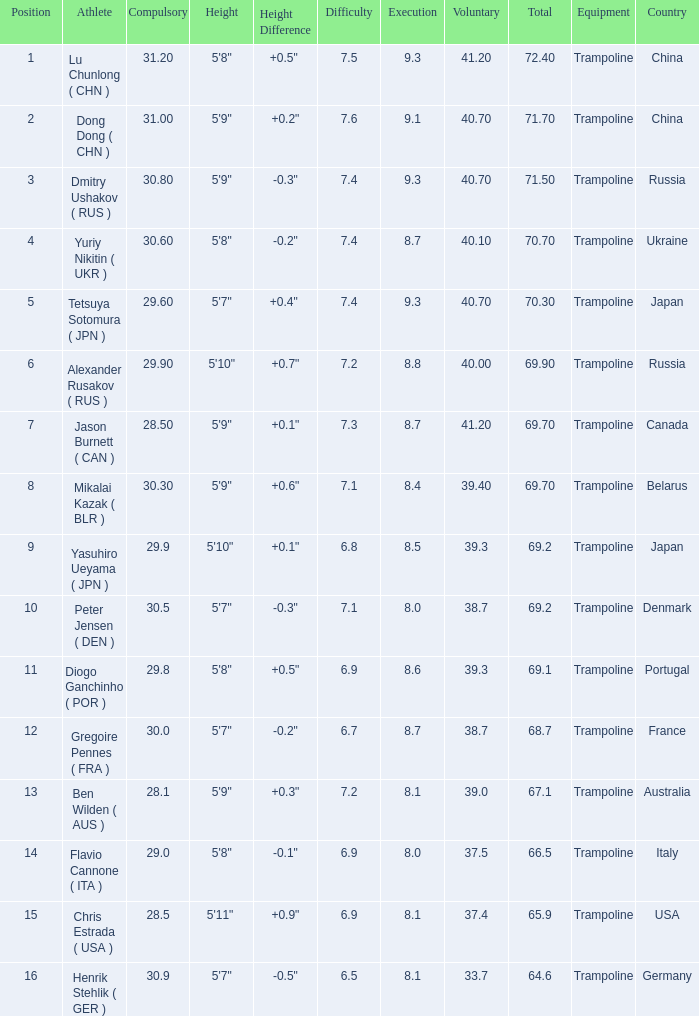Could you parse the entire table as a dict? {'header': ['Position', 'Athlete', 'Compulsory', 'Height', 'Height Difference', 'Difficulty', 'Execution', 'Voluntary', 'Total', 'Equipment', 'Country'], 'rows': [['1', 'Lu Chunlong ( CHN )', '31.20', '5\'8"', '+0.5" ', '7.5', '9.3', '41.20', '72.40', 'Trampoline', 'China'], ['2', 'Dong Dong ( CHN )', '31.00', '5\'9"', '+0.2"', '7.6', '9.1', '40.70', '71.70', 'Trampoline', 'China'], ['3', 'Dmitry Ushakov ( RUS )', '30.80', '5\'9"', '-0.3"', '7.4', '9.3', '40.70', '71.50', 'Trampoline', 'Russia'], ['4', 'Yuriy Nikitin ( UKR )', '30.60', '5\'8"', '-0.2"', '7.4', '8.7', '40.10', '70.70', 'Trampoline', 'Ukraine'], ['5', 'Tetsuya Sotomura ( JPN )', '29.60', '5\'7"', '+0.4" ', '7.4', '9.3', '40.70', '70.30', 'Trampoline', 'Japan'], ['6', 'Alexander Rusakov ( RUS )', '29.90', '5\'10"', '+0.7"', '7.2', '8.8', '40.00', '69.90', 'Trampoline', 'Russia'], ['7', 'Jason Burnett ( CAN )', '28.50', '5\'9"', '+0.1"', '7.3', '8.7', '41.20', '69.70', 'Trampoline', 'Canada'], ['8', 'Mikalai Kazak ( BLR )', '30.30', '5\'9"', '+0.6"', '7.1', '8.4', '39.40', '69.70', 'Trampoline', 'Belarus'], ['9', 'Yasuhiro Ueyama ( JPN )', '29.9', '5\'10" ', '+0.1"', '6.8', '8.5', '39.3', '69.2', 'Trampoline', 'Japan'], ['10', 'Peter Jensen ( DEN )', '30.5', '5\'7"', '-0.3"', '7.1', '8.0', '38.7', '69.2', 'Trampoline', 'Denmark'], ['11', 'Diogo Ganchinho ( POR )', '29.8', '5\'8"', '+0.5"', '6.9', '8.6', '39.3', '69.1', 'Trampoline', 'Portugal'], ['12', 'Gregoire Pennes ( FRA )', '30.0', '5\'7"', '-0.2"', '6.7', '8.7', '38.7', '68.7', 'Trampoline', 'France'], ['13', 'Ben Wilden ( AUS )', '28.1', '5\'9"', '+0.3"', '7.2', '8.1', '39.0', '67.1', 'Trampoline', 'Australia'], ['14', 'Flavio Cannone ( ITA )', '29.0', '5\'8"', '-0.1"', '6.9', '8.0', '37.5', '66.5', 'Trampoline', 'Italy'], ['15', 'Chris Estrada ( USA )', '28.5', '5\'11" ', '+0.9"', '6.9', '8.1', '37.4', '65.9', 'Trampoline', 'USA'], ['16', 'Henrik Stehlik ( GER )', '30.9', '5\'7"', '-0.5"', '6.5', '8.1', '33.7', '64.6', 'Trampoline', 'Germany']]} What's the total of the position of 1? None. 